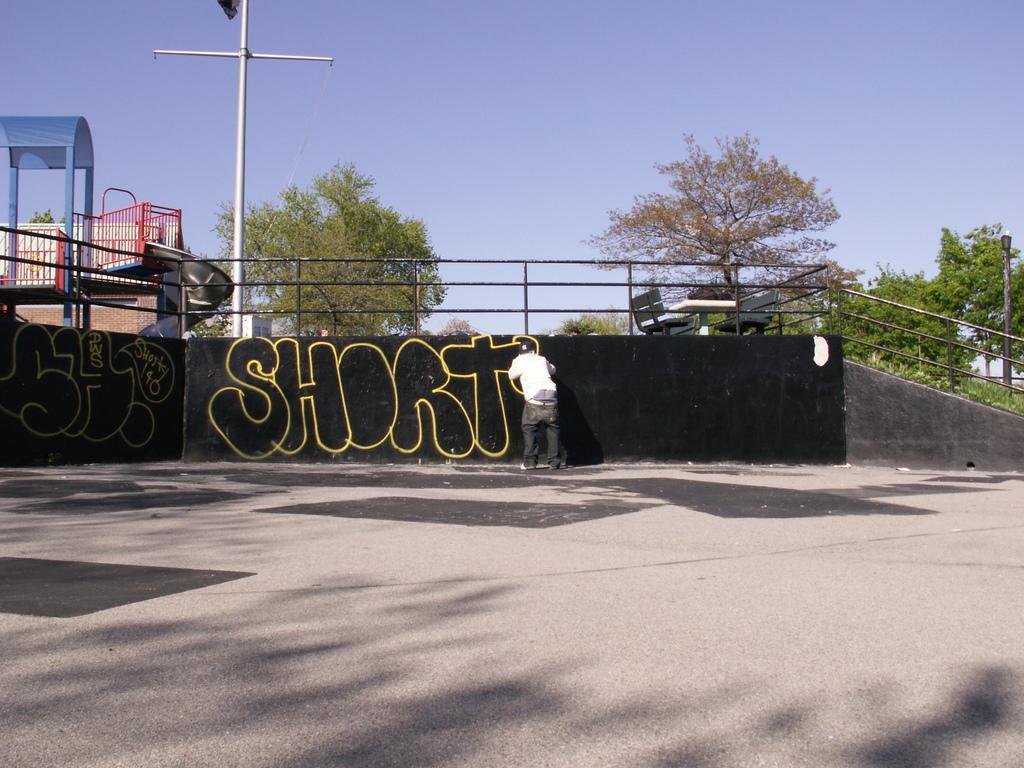Could you give a brief overview of what you see in this image? At the bottom of the image there is road. And also there is a wall with graffiti. In front of the wall there is a person standing. And there is a railing. Behind the railing there is a table and also there are benches. On the left corner of the image behind the railing there is a slide with roof and railings. In the background there is a pole. And also there are trees. At the top of the image there is sky. 